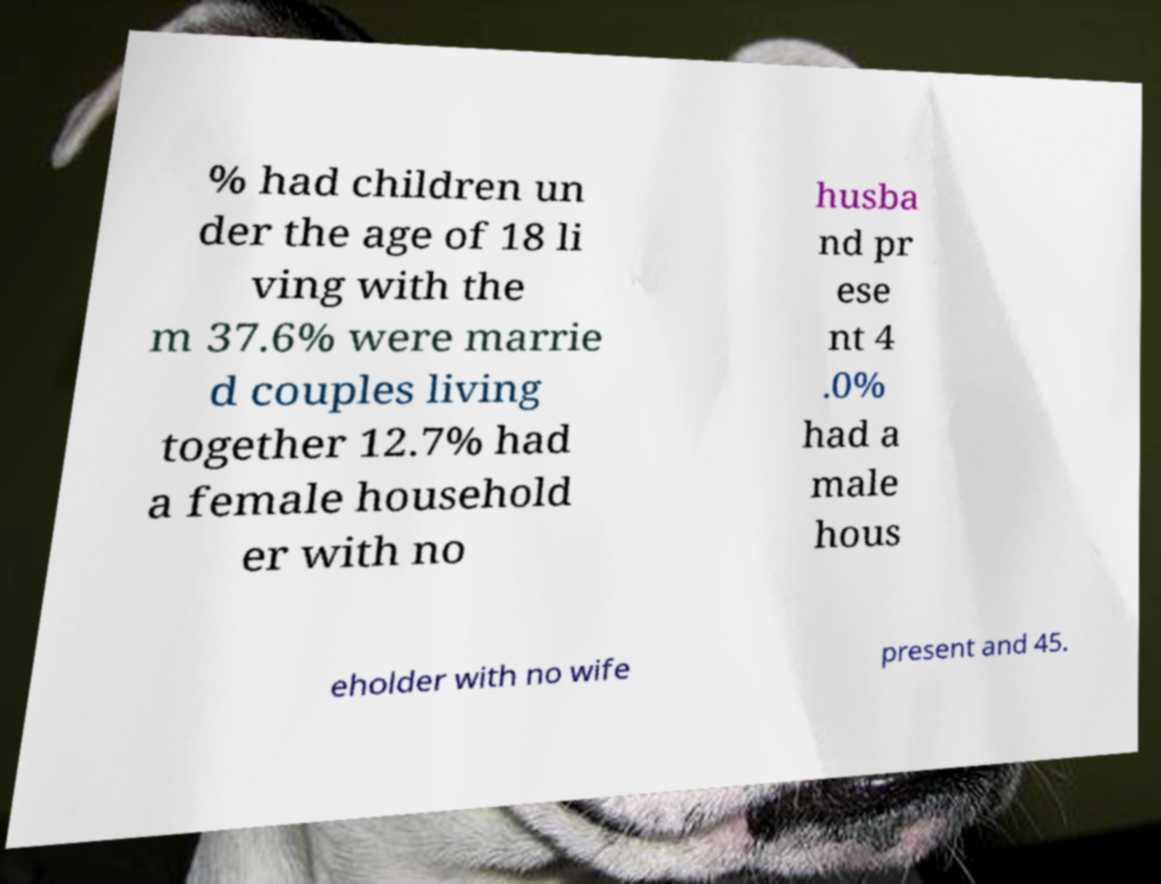Could you extract and type out the text from this image? % had children un der the age of 18 li ving with the m 37.6% were marrie d couples living together 12.7% had a female household er with no husba nd pr ese nt 4 .0% had a male hous eholder with no wife present and 45. 